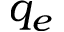Convert formula to latex. <formula><loc_0><loc_0><loc_500><loc_500>q _ { e }</formula> 